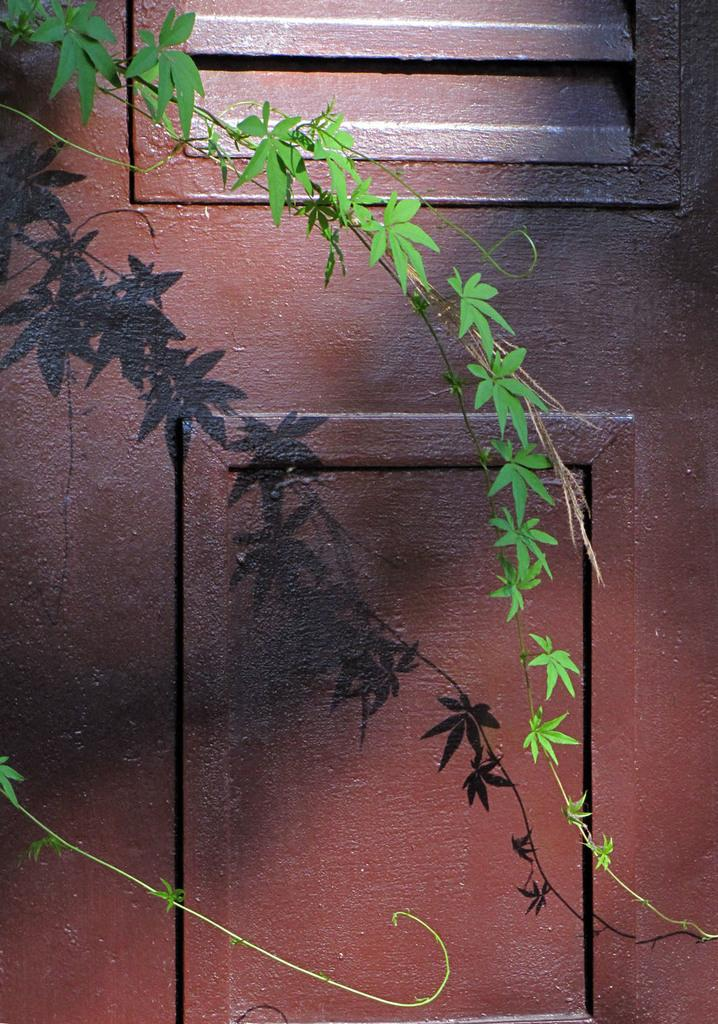What type of plant can be seen in the image? There is a plant with green leaves in the image. What is visible in the background of the image? There is a door in the background of the image. What is the color of the door? The door is red in color. Can you describe any other features related to the plant in the image? There is a shadow of a plant in the background of the image. What type of store is visible in the image? There is no store visible in the image; it features a plant with green leaves and a red door in the background. What meal is being prepared in the image? There is no meal preparation visible in the image; it only shows a plant and a red door. 